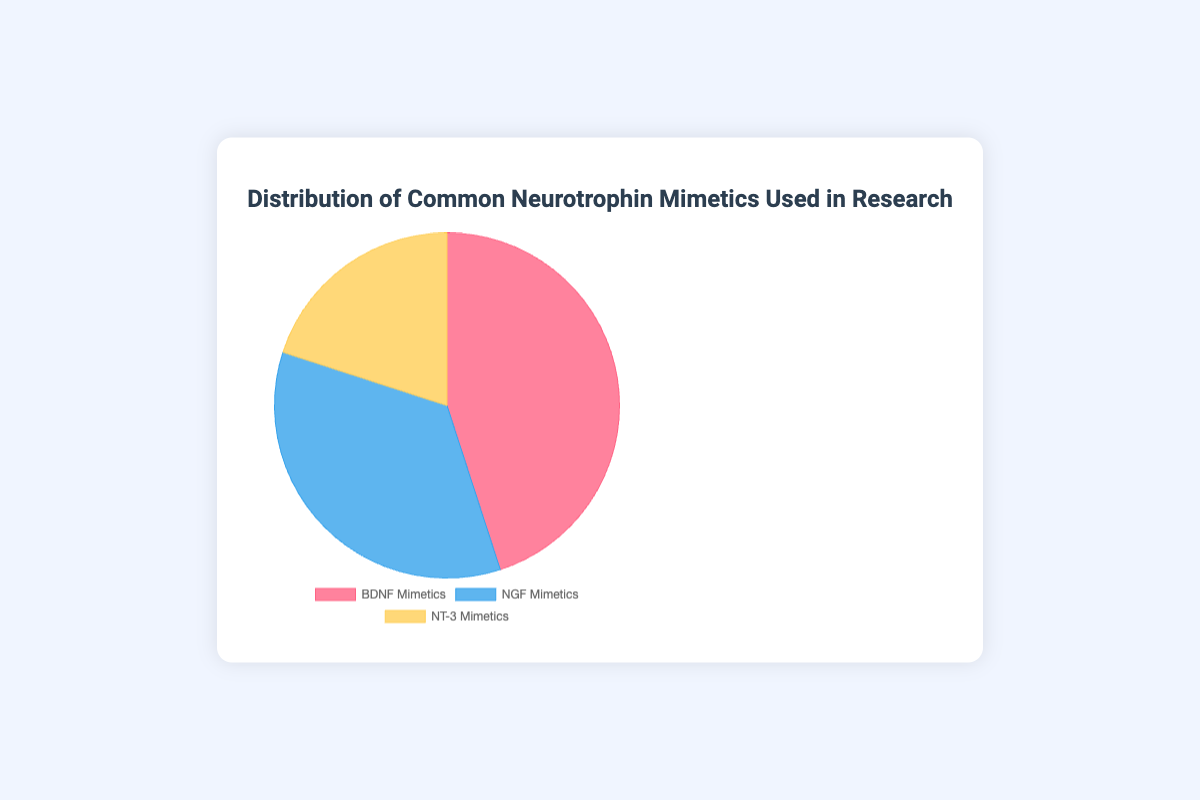What percentage of the pie chart is represented by BDNF Mimetics? The value for BDNF Mimetics is 45%. This percentage is directly given in the data provided.
Answer: 45% Which type of neurotrophin mimetic has the smallest representation in the chart? The value for NT-3 Mimetics is 20%, which is the smallest percentage compared to BDNF Mimetics (45%) and NGF Mimetics (35%).
Answer: NT-3 Mimetics How many more percentage points do BDNF Mimetics have compared to NT-3 Mimetics? BDNF Mimetics have 45% and NT-3 Mimetics have 20%. The difference is 45% - 20% = 25%.
Answer: 25% What is the combined percentage of NGF Mimetics and NT-3 Mimetics? NGF Mimetics are 35% and NT-3 Mimetics are 20%. Their combined percentage is 35% + 20% = 55%.
Answer: 55% If the entire pie chart represents 100 studies, how many studies used NGF Mimetics? NGF Mimetics represent 35% of the pie chart. 35% of 100 studies is 0.35 * 100 = 35 studies.
Answer: 35 studies What proportion of the chart is represented by NGF Mimetics relative to BDNF Mimetics? NGF Mimetics are 35% and BDNF Mimetics are 45%. The ratio is 35% to 45%, which can be simplified to 35 / 45 = 7 / 9.
Answer: 7/9 Which sector of the pie chart is represented by the blue color? According to the color legend, NGF Mimetics are represented by the blue color.
Answer: NGF Mimetics By how many percentage points does NGF Mimetics exceed NT-3 Mimetics? NGF Mimetics have 35% and NT-3 Mimetics have 20%. The difference is 35% - 20% = 15%.
Answer: 15% What is the average percentage of the three neurotrophin mimetics categories? To find the average, add the percentages of BDNF Mimetics (45%), NGF Mimetics (35%), and NT-3 Mimetics (20%). The total is 45% + 35% + 20% = 100%, and the average is 100% / 3 = 33.33%.
Answer: 33.33% What is the difference between the percentage of the least and the most represented mimetic? The least represented is NT-3 Mimetics at 20% and the most represented is BDNF Mimetics at 45%. The difference is 45% - 20% = 25%.
Answer: 25% 